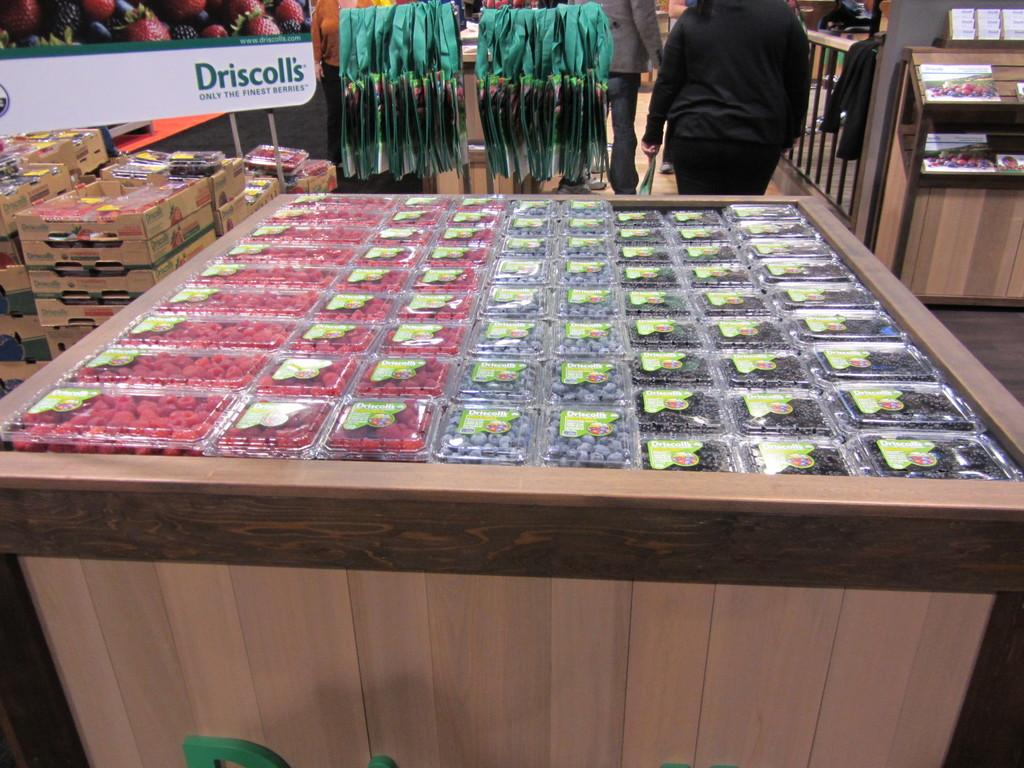<image>
Share a concise interpretation of the image provided. A sign for Driscolis sits above a large case of berries 